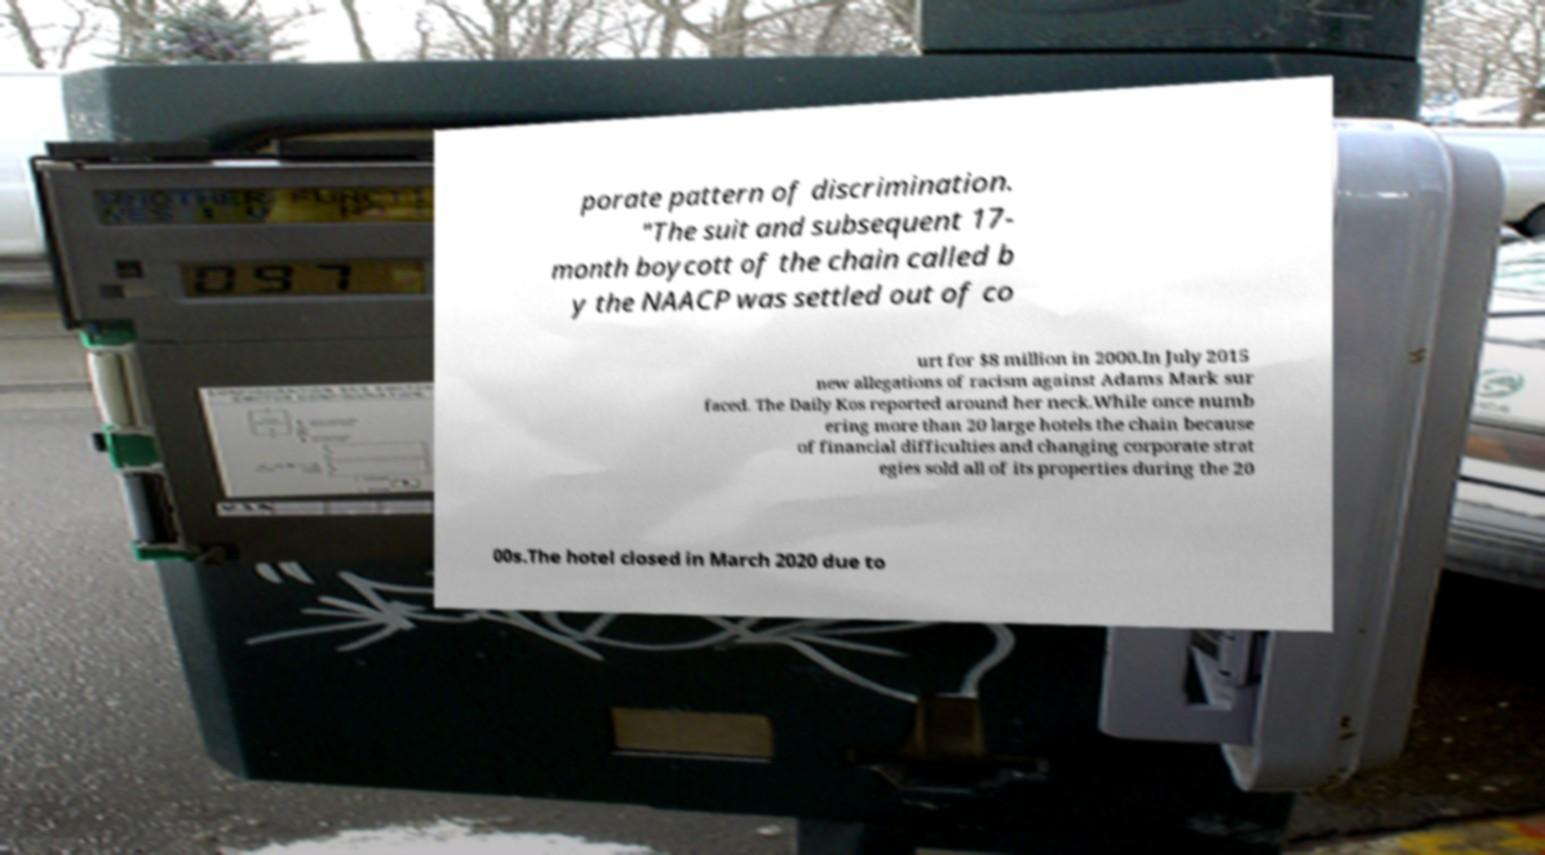Could you assist in decoding the text presented in this image and type it out clearly? porate pattern of discrimination. "The suit and subsequent 17- month boycott of the chain called b y the NAACP was settled out of co urt for $8 million in 2000.In July 2015 new allegations of racism against Adams Mark sur faced. The Daily Kos reported around her neck.While once numb ering more than 20 large hotels the chain because of financial difficulties and changing corporate strat egies sold all of its properties during the 20 00s.The hotel closed in March 2020 due to 